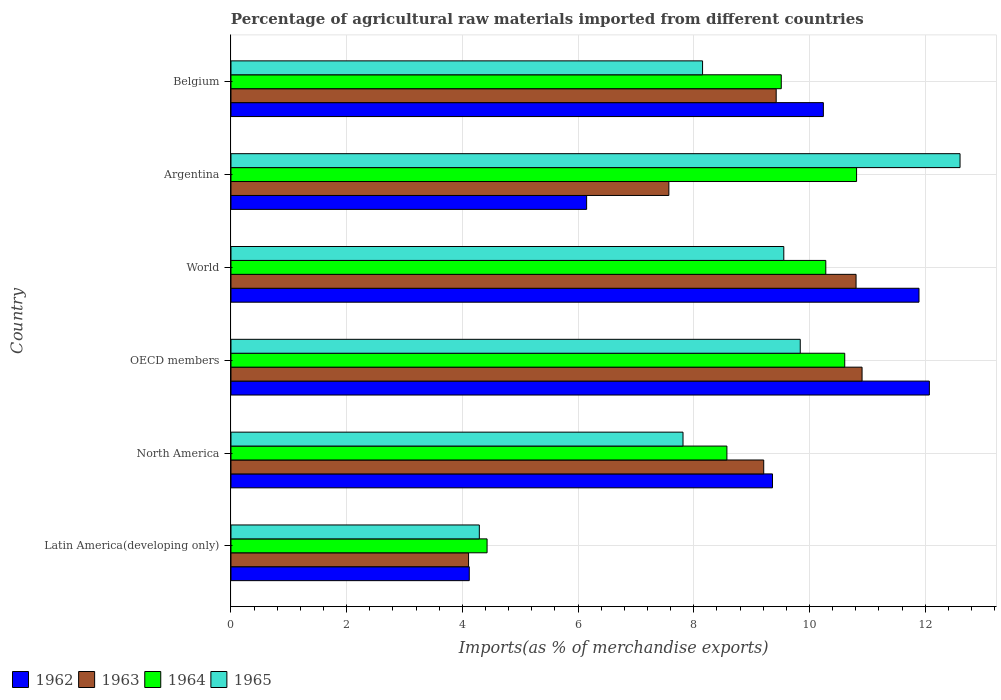How many different coloured bars are there?
Your answer should be very brief. 4. How many groups of bars are there?
Provide a succinct answer. 6. Are the number of bars per tick equal to the number of legend labels?
Offer a very short reply. Yes. Are the number of bars on each tick of the Y-axis equal?
Offer a very short reply. Yes. What is the label of the 2nd group of bars from the top?
Make the answer very short. Argentina. In how many cases, is the number of bars for a given country not equal to the number of legend labels?
Offer a terse response. 0. What is the percentage of imports to different countries in 1962 in Belgium?
Your response must be concise. 10.24. Across all countries, what is the maximum percentage of imports to different countries in 1965?
Ensure brevity in your answer.  12.6. Across all countries, what is the minimum percentage of imports to different countries in 1962?
Give a very brief answer. 4.12. In which country was the percentage of imports to different countries in 1962 minimum?
Offer a very short reply. Latin America(developing only). What is the total percentage of imports to different countries in 1963 in the graph?
Make the answer very short. 52.02. What is the difference between the percentage of imports to different countries in 1965 in Argentina and that in World?
Provide a succinct answer. 3.05. What is the difference between the percentage of imports to different countries in 1962 in OECD members and the percentage of imports to different countries in 1964 in Latin America(developing only)?
Offer a very short reply. 7.64. What is the average percentage of imports to different countries in 1962 per country?
Keep it short and to the point. 8.97. What is the difference between the percentage of imports to different countries in 1962 and percentage of imports to different countries in 1965 in World?
Your answer should be very brief. 2.34. What is the ratio of the percentage of imports to different countries in 1965 in Argentina to that in World?
Offer a terse response. 1.32. Is the difference between the percentage of imports to different countries in 1962 in Argentina and Latin America(developing only) greater than the difference between the percentage of imports to different countries in 1965 in Argentina and Latin America(developing only)?
Provide a succinct answer. No. What is the difference between the highest and the second highest percentage of imports to different countries in 1962?
Give a very brief answer. 0.18. What is the difference between the highest and the lowest percentage of imports to different countries in 1963?
Offer a terse response. 6.8. In how many countries, is the percentage of imports to different countries in 1963 greater than the average percentage of imports to different countries in 1963 taken over all countries?
Your response must be concise. 4. What does the 3rd bar from the bottom in OECD members represents?
Your response must be concise. 1964. Are all the bars in the graph horizontal?
Keep it short and to the point. Yes. How many countries are there in the graph?
Ensure brevity in your answer.  6. What is the difference between two consecutive major ticks on the X-axis?
Provide a succinct answer. 2. Does the graph contain any zero values?
Keep it short and to the point. No. Does the graph contain grids?
Your response must be concise. Yes. Where does the legend appear in the graph?
Ensure brevity in your answer.  Bottom left. How many legend labels are there?
Provide a succinct answer. 4. What is the title of the graph?
Ensure brevity in your answer.  Percentage of agricultural raw materials imported from different countries. What is the label or title of the X-axis?
Keep it short and to the point. Imports(as % of merchandise exports). What is the Imports(as % of merchandise exports) in 1962 in Latin America(developing only)?
Your response must be concise. 4.12. What is the Imports(as % of merchandise exports) of 1963 in Latin America(developing only)?
Your answer should be compact. 4.11. What is the Imports(as % of merchandise exports) in 1964 in Latin America(developing only)?
Make the answer very short. 4.43. What is the Imports(as % of merchandise exports) of 1965 in Latin America(developing only)?
Your answer should be compact. 4.29. What is the Imports(as % of merchandise exports) in 1962 in North America?
Provide a succinct answer. 9.36. What is the Imports(as % of merchandise exports) of 1963 in North America?
Provide a short and direct response. 9.21. What is the Imports(as % of merchandise exports) in 1964 in North America?
Your response must be concise. 8.57. What is the Imports(as % of merchandise exports) in 1965 in North America?
Provide a short and direct response. 7.81. What is the Imports(as % of merchandise exports) in 1962 in OECD members?
Make the answer very short. 12.07. What is the Imports(as % of merchandise exports) of 1963 in OECD members?
Make the answer very short. 10.91. What is the Imports(as % of merchandise exports) in 1964 in OECD members?
Provide a succinct answer. 10.61. What is the Imports(as % of merchandise exports) in 1965 in OECD members?
Your answer should be very brief. 9.84. What is the Imports(as % of merchandise exports) in 1962 in World?
Keep it short and to the point. 11.89. What is the Imports(as % of merchandise exports) in 1963 in World?
Keep it short and to the point. 10.8. What is the Imports(as % of merchandise exports) in 1964 in World?
Your response must be concise. 10.28. What is the Imports(as % of merchandise exports) of 1965 in World?
Make the answer very short. 9.56. What is the Imports(as % of merchandise exports) in 1962 in Argentina?
Your response must be concise. 6.15. What is the Imports(as % of merchandise exports) of 1963 in Argentina?
Ensure brevity in your answer.  7.57. What is the Imports(as % of merchandise exports) of 1964 in Argentina?
Provide a succinct answer. 10.81. What is the Imports(as % of merchandise exports) in 1965 in Argentina?
Provide a short and direct response. 12.6. What is the Imports(as % of merchandise exports) of 1962 in Belgium?
Your answer should be very brief. 10.24. What is the Imports(as % of merchandise exports) of 1963 in Belgium?
Make the answer very short. 9.42. What is the Imports(as % of merchandise exports) of 1964 in Belgium?
Provide a succinct answer. 9.51. What is the Imports(as % of merchandise exports) of 1965 in Belgium?
Your response must be concise. 8.15. Across all countries, what is the maximum Imports(as % of merchandise exports) in 1962?
Provide a succinct answer. 12.07. Across all countries, what is the maximum Imports(as % of merchandise exports) in 1963?
Provide a short and direct response. 10.91. Across all countries, what is the maximum Imports(as % of merchandise exports) of 1964?
Give a very brief answer. 10.81. Across all countries, what is the maximum Imports(as % of merchandise exports) in 1965?
Provide a succinct answer. 12.6. Across all countries, what is the minimum Imports(as % of merchandise exports) of 1962?
Keep it short and to the point. 4.12. Across all countries, what is the minimum Imports(as % of merchandise exports) in 1963?
Your answer should be compact. 4.11. Across all countries, what is the minimum Imports(as % of merchandise exports) in 1964?
Your answer should be compact. 4.43. Across all countries, what is the minimum Imports(as % of merchandise exports) of 1965?
Your answer should be very brief. 4.29. What is the total Imports(as % of merchandise exports) of 1962 in the graph?
Your answer should be compact. 53.83. What is the total Imports(as % of merchandise exports) of 1963 in the graph?
Keep it short and to the point. 52.02. What is the total Imports(as % of merchandise exports) of 1964 in the graph?
Give a very brief answer. 54.21. What is the total Imports(as % of merchandise exports) in 1965 in the graph?
Make the answer very short. 52.25. What is the difference between the Imports(as % of merchandise exports) in 1962 in Latin America(developing only) and that in North America?
Your answer should be compact. -5.24. What is the difference between the Imports(as % of merchandise exports) of 1963 in Latin America(developing only) and that in North America?
Your answer should be very brief. -5.1. What is the difference between the Imports(as % of merchandise exports) in 1964 in Latin America(developing only) and that in North America?
Your answer should be compact. -4.15. What is the difference between the Imports(as % of merchandise exports) of 1965 in Latin America(developing only) and that in North America?
Offer a terse response. -3.52. What is the difference between the Imports(as % of merchandise exports) in 1962 in Latin America(developing only) and that in OECD members?
Make the answer very short. -7.95. What is the difference between the Imports(as % of merchandise exports) of 1963 in Latin America(developing only) and that in OECD members?
Your answer should be compact. -6.8. What is the difference between the Imports(as % of merchandise exports) of 1964 in Latin America(developing only) and that in OECD members?
Give a very brief answer. -6.18. What is the difference between the Imports(as % of merchandise exports) of 1965 in Latin America(developing only) and that in OECD members?
Make the answer very short. -5.55. What is the difference between the Imports(as % of merchandise exports) of 1962 in Latin America(developing only) and that in World?
Make the answer very short. -7.77. What is the difference between the Imports(as % of merchandise exports) in 1963 in Latin America(developing only) and that in World?
Your answer should be compact. -6.7. What is the difference between the Imports(as % of merchandise exports) of 1964 in Latin America(developing only) and that in World?
Keep it short and to the point. -5.85. What is the difference between the Imports(as % of merchandise exports) of 1965 in Latin America(developing only) and that in World?
Ensure brevity in your answer.  -5.26. What is the difference between the Imports(as % of merchandise exports) of 1962 in Latin America(developing only) and that in Argentina?
Provide a succinct answer. -2.03. What is the difference between the Imports(as % of merchandise exports) in 1963 in Latin America(developing only) and that in Argentina?
Your answer should be very brief. -3.46. What is the difference between the Imports(as % of merchandise exports) of 1964 in Latin America(developing only) and that in Argentina?
Your answer should be very brief. -6.39. What is the difference between the Imports(as % of merchandise exports) in 1965 in Latin America(developing only) and that in Argentina?
Keep it short and to the point. -8.31. What is the difference between the Imports(as % of merchandise exports) in 1962 in Latin America(developing only) and that in Belgium?
Ensure brevity in your answer.  -6.12. What is the difference between the Imports(as % of merchandise exports) of 1963 in Latin America(developing only) and that in Belgium?
Provide a short and direct response. -5.32. What is the difference between the Imports(as % of merchandise exports) of 1964 in Latin America(developing only) and that in Belgium?
Ensure brevity in your answer.  -5.08. What is the difference between the Imports(as % of merchandise exports) of 1965 in Latin America(developing only) and that in Belgium?
Keep it short and to the point. -3.86. What is the difference between the Imports(as % of merchandise exports) in 1962 in North America and that in OECD members?
Give a very brief answer. -2.71. What is the difference between the Imports(as % of merchandise exports) in 1963 in North America and that in OECD members?
Your response must be concise. -1.7. What is the difference between the Imports(as % of merchandise exports) in 1964 in North America and that in OECD members?
Offer a very short reply. -2.04. What is the difference between the Imports(as % of merchandise exports) in 1965 in North America and that in OECD members?
Your answer should be compact. -2.03. What is the difference between the Imports(as % of merchandise exports) of 1962 in North America and that in World?
Offer a terse response. -2.53. What is the difference between the Imports(as % of merchandise exports) of 1963 in North America and that in World?
Your response must be concise. -1.6. What is the difference between the Imports(as % of merchandise exports) of 1964 in North America and that in World?
Offer a very short reply. -1.71. What is the difference between the Imports(as % of merchandise exports) in 1965 in North America and that in World?
Offer a terse response. -1.74. What is the difference between the Imports(as % of merchandise exports) in 1962 in North America and that in Argentina?
Make the answer very short. 3.21. What is the difference between the Imports(as % of merchandise exports) in 1963 in North America and that in Argentina?
Keep it short and to the point. 1.64. What is the difference between the Imports(as % of merchandise exports) in 1964 in North America and that in Argentina?
Your answer should be very brief. -2.24. What is the difference between the Imports(as % of merchandise exports) in 1965 in North America and that in Argentina?
Offer a terse response. -4.79. What is the difference between the Imports(as % of merchandise exports) of 1962 in North America and that in Belgium?
Offer a terse response. -0.88. What is the difference between the Imports(as % of merchandise exports) in 1963 in North America and that in Belgium?
Keep it short and to the point. -0.22. What is the difference between the Imports(as % of merchandise exports) of 1964 in North America and that in Belgium?
Offer a terse response. -0.94. What is the difference between the Imports(as % of merchandise exports) of 1965 in North America and that in Belgium?
Your answer should be compact. -0.34. What is the difference between the Imports(as % of merchandise exports) in 1962 in OECD members and that in World?
Your answer should be very brief. 0.18. What is the difference between the Imports(as % of merchandise exports) of 1963 in OECD members and that in World?
Make the answer very short. 0.1. What is the difference between the Imports(as % of merchandise exports) in 1964 in OECD members and that in World?
Your answer should be very brief. 0.33. What is the difference between the Imports(as % of merchandise exports) in 1965 in OECD members and that in World?
Your response must be concise. 0.28. What is the difference between the Imports(as % of merchandise exports) in 1962 in OECD members and that in Argentina?
Your answer should be compact. 5.92. What is the difference between the Imports(as % of merchandise exports) in 1963 in OECD members and that in Argentina?
Give a very brief answer. 3.34. What is the difference between the Imports(as % of merchandise exports) of 1964 in OECD members and that in Argentina?
Keep it short and to the point. -0.2. What is the difference between the Imports(as % of merchandise exports) of 1965 in OECD members and that in Argentina?
Your response must be concise. -2.76. What is the difference between the Imports(as % of merchandise exports) of 1962 in OECD members and that in Belgium?
Ensure brevity in your answer.  1.83. What is the difference between the Imports(as % of merchandise exports) in 1963 in OECD members and that in Belgium?
Give a very brief answer. 1.48. What is the difference between the Imports(as % of merchandise exports) of 1964 in OECD members and that in Belgium?
Offer a terse response. 1.1. What is the difference between the Imports(as % of merchandise exports) in 1965 in OECD members and that in Belgium?
Keep it short and to the point. 1.69. What is the difference between the Imports(as % of merchandise exports) of 1962 in World and that in Argentina?
Ensure brevity in your answer.  5.74. What is the difference between the Imports(as % of merchandise exports) of 1963 in World and that in Argentina?
Offer a very short reply. 3.24. What is the difference between the Imports(as % of merchandise exports) in 1964 in World and that in Argentina?
Your response must be concise. -0.53. What is the difference between the Imports(as % of merchandise exports) of 1965 in World and that in Argentina?
Keep it short and to the point. -3.05. What is the difference between the Imports(as % of merchandise exports) in 1962 in World and that in Belgium?
Your response must be concise. 1.65. What is the difference between the Imports(as % of merchandise exports) of 1963 in World and that in Belgium?
Offer a terse response. 1.38. What is the difference between the Imports(as % of merchandise exports) in 1964 in World and that in Belgium?
Make the answer very short. 0.77. What is the difference between the Imports(as % of merchandise exports) in 1965 in World and that in Belgium?
Give a very brief answer. 1.4. What is the difference between the Imports(as % of merchandise exports) in 1962 in Argentina and that in Belgium?
Offer a terse response. -4.09. What is the difference between the Imports(as % of merchandise exports) of 1963 in Argentina and that in Belgium?
Offer a very short reply. -1.86. What is the difference between the Imports(as % of merchandise exports) of 1964 in Argentina and that in Belgium?
Provide a succinct answer. 1.3. What is the difference between the Imports(as % of merchandise exports) of 1965 in Argentina and that in Belgium?
Provide a succinct answer. 4.45. What is the difference between the Imports(as % of merchandise exports) in 1962 in Latin America(developing only) and the Imports(as % of merchandise exports) in 1963 in North America?
Keep it short and to the point. -5.09. What is the difference between the Imports(as % of merchandise exports) in 1962 in Latin America(developing only) and the Imports(as % of merchandise exports) in 1964 in North America?
Provide a short and direct response. -4.45. What is the difference between the Imports(as % of merchandise exports) of 1962 in Latin America(developing only) and the Imports(as % of merchandise exports) of 1965 in North America?
Give a very brief answer. -3.69. What is the difference between the Imports(as % of merchandise exports) of 1963 in Latin America(developing only) and the Imports(as % of merchandise exports) of 1964 in North America?
Make the answer very short. -4.47. What is the difference between the Imports(as % of merchandise exports) of 1963 in Latin America(developing only) and the Imports(as % of merchandise exports) of 1965 in North America?
Provide a short and direct response. -3.71. What is the difference between the Imports(as % of merchandise exports) of 1964 in Latin America(developing only) and the Imports(as % of merchandise exports) of 1965 in North America?
Your answer should be very brief. -3.39. What is the difference between the Imports(as % of merchandise exports) in 1962 in Latin America(developing only) and the Imports(as % of merchandise exports) in 1963 in OECD members?
Offer a very short reply. -6.79. What is the difference between the Imports(as % of merchandise exports) in 1962 in Latin America(developing only) and the Imports(as % of merchandise exports) in 1964 in OECD members?
Give a very brief answer. -6.49. What is the difference between the Imports(as % of merchandise exports) of 1962 in Latin America(developing only) and the Imports(as % of merchandise exports) of 1965 in OECD members?
Keep it short and to the point. -5.72. What is the difference between the Imports(as % of merchandise exports) in 1963 in Latin America(developing only) and the Imports(as % of merchandise exports) in 1964 in OECD members?
Offer a terse response. -6.5. What is the difference between the Imports(as % of merchandise exports) of 1963 in Latin America(developing only) and the Imports(as % of merchandise exports) of 1965 in OECD members?
Your answer should be compact. -5.73. What is the difference between the Imports(as % of merchandise exports) in 1964 in Latin America(developing only) and the Imports(as % of merchandise exports) in 1965 in OECD members?
Ensure brevity in your answer.  -5.41. What is the difference between the Imports(as % of merchandise exports) of 1962 in Latin America(developing only) and the Imports(as % of merchandise exports) of 1963 in World?
Make the answer very short. -6.69. What is the difference between the Imports(as % of merchandise exports) in 1962 in Latin America(developing only) and the Imports(as % of merchandise exports) in 1964 in World?
Offer a terse response. -6.16. What is the difference between the Imports(as % of merchandise exports) of 1962 in Latin America(developing only) and the Imports(as % of merchandise exports) of 1965 in World?
Your answer should be compact. -5.44. What is the difference between the Imports(as % of merchandise exports) in 1963 in Latin America(developing only) and the Imports(as % of merchandise exports) in 1964 in World?
Provide a succinct answer. -6.17. What is the difference between the Imports(as % of merchandise exports) in 1963 in Latin America(developing only) and the Imports(as % of merchandise exports) in 1965 in World?
Offer a terse response. -5.45. What is the difference between the Imports(as % of merchandise exports) of 1964 in Latin America(developing only) and the Imports(as % of merchandise exports) of 1965 in World?
Your answer should be very brief. -5.13. What is the difference between the Imports(as % of merchandise exports) of 1962 in Latin America(developing only) and the Imports(as % of merchandise exports) of 1963 in Argentina?
Your response must be concise. -3.45. What is the difference between the Imports(as % of merchandise exports) of 1962 in Latin America(developing only) and the Imports(as % of merchandise exports) of 1964 in Argentina?
Offer a terse response. -6.69. What is the difference between the Imports(as % of merchandise exports) of 1962 in Latin America(developing only) and the Imports(as % of merchandise exports) of 1965 in Argentina?
Provide a succinct answer. -8.48. What is the difference between the Imports(as % of merchandise exports) of 1963 in Latin America(developing only) and the Imports(as % of merchandise exports) of 1964 in Argentina?
Your response must be concise. -6.71. What is the difference between the Imports(as % of merchandise exports) of 1963 in Latin America(developing only) and the Imports(as % of merchandise exports) of 1965 in Argentina?
Ensure brevity in your answer.  -8.49. What is the difference between the Imports(as % of merchandise exports) of 1964 in Latin America(developing only) and the Imports(as % of merchandise exports) of 1965 in Argentina?
Ensure brevity in your answer.  -8.17. What is the difference between the Imports(as % of merchandise exports) of 1962 in Latin America(developing only) and the Imports(as % of merchandise exports) of 1963 in Belgium?
Keep it short and to the point. -5.3. What is the difference between the Imports(as % of merchandise exports) of 1962 in Latin America(developing only) and the Imports(as % of merchandise exports) of 1964 in Belgium?
Provide a short and direct response. -5.39. What is the difference between the Imports(as % of merchandise exports) in 1962 in Latin America(developing only) and the Imports(as % of merchandise exports) in 1965 in Belgium?
Offer a very short reply. -4.03. What is the difference between the Imports(as % of merchandise exports) of 1963 in Latin America(developing only) and the Imports(as % of merchandise exports) of 1964 in Belgium?
Give a very brief answer. -5.4. What is the difference between the Imports(as % of merchandise exports) of 1963 in Latin America(developing only) and the Imports(as % of merchandise exports) of 1965 in Belgium?
Your answer should be compact. -4.04. What is the difference between the Imports(as % of merchandise exports) in 1964 in Latin America(developing only) and the Imports(as % of merchandise exports) in 1965 in Belgium?
Offer a very short reply. -3.72. What is the difference between the Imports(as % of merchandise exports) of 1962 in North America and the Imports(as % of merchandise exports) of 1963 in OECD members?
Make the answer very short. -1.55. What is the difference between the Imports(as % of merchandise exports) in 1962 in North America and the Imports(as % of merchandise exports) in 1964 in OECD members?
Make the answer very short. -1.25. What is the difference between the Imports(as % of merchandise exports) in 1962 in North America and the Imports(as % of merchandise exports) in 1965 in OECD members?
Provide a short and direct response. -0.48. What is the difference between the Imports(as % of merchandise exports) of 1963 in North America and the Imports(as % of merchandise exports) of 1964 in OECD members?
Your answer should be very brief. -1.4. What is the difference between the Imports(as % of merchandise exports) in 1963 in North America and the Imports(as % of merchandise exports) in 1965 in OECD members?
Your answer should be very brief. -0.63. What is the difference between the Imports(as % of merchandise exports) of 1964 in North America and the Imports(as % of merchandise exports) of 1965 in OECD members?
Ensure brevity in your answer.  -1.27. What is the difference between the Imports(as % of merchandise exports) in 1962 in North America and the Imports(as % of merchandise exports) in 1963 in World?
Your answer should be very brief. -1.44. What is the difference between the Imports(as % of merchandise exports) of 1962 in North America and the Imports(as % of merchandise exports) of 1964 in World?
Offer a very short reply. -0.92. What is the difference between the Imports(as % of merchandise exports) of 1962 in North America and the Imports(as % of merchandise exports) of 1965 in World?
Offer a very short reply. -0.2. What is the difference between the Imports(as % of merchandise exports) of 1963 in North America and the Imports(as % of merchandise exports) of 1964 in World?
Give a very brief answer. -1.07. What is the difference between the Imports(as % of merchandise exports) in 1963 in North America and the Imports(as % of merchandise exports) in 1965 in World?
Provide a succinct answer. -0.35. What is the difference between the Imports(as % of merchandise exports) of 1964 in North America and the Imports(as % of merchandise exports) of 1965 in World?
Your answer should be compact. -0.98. What is the difference between the Imports(as % of merchandise exports) of 1962 in North America and the Imports(as % of merchandise exports) of 1963 in Argentina?
Your answer should be very brief. 1.79. What is the difference between the Imports(as % of merchandise exports) of 1962 in North America and the Imports(as % of merchandise exports) of 1964 in Argentina?
Give a very brief answer. -1.45. What is the difference between the Imports(as % of merchandise exports) of 1962 in North America and the Imports(as % of merchandise exports) of 1965 in Argentina?
Your answer should be compact. -3.24. What is the difference between the Imports(as % of merchandise exports) in 1963 in North America and the Imports(as % of merchandise exports) in 1964 in Argentina?
Offer a terse response. -1.61. What is the difference between the Imports(as % of merchandise exports) in 1963 in North America and the Imports(as % of merchandise exports) in 1965 in Argentina?
Provide a short and direct response. -3.39. What is the difference between the Imports(as % of merchandise exports) of 1964 in North America and the Imports(as % of merchandise exports) of 1965 in Argentina?
Offer a very short reply. -4.03. What is the difference between the Imports(as % of merchandise exports) in 1962 in North America and the Imports(as % of merchandise exports) in 1963 in Belgium?
Your response must be concise. -0.06. What is the difference between the Imports(as % of merchandise exports) in 1962 in North America and the Imports(as % of merchandise exports) in 1964 in Belgium?
Offer a very short reply. -0.15. What is the difference between the Imports(as % of merchandise exports) in 1962 in North America and the Imports(as % of merchandise exports) in 1965 in Belgium?
Offer a very short reply. 1.21. What is the difference between the Imports(as % of merchandise exports) of 1963 in North America and the Imports(as % of merchandise exports) of 1964 in Belgium?
Keep it short and to the point. -0.3. What is the difference between the Imports(as % of merchandise exports) in 1963 in North America and the Imports(as % of merchandise exports) in 1965 in Belgium?
Your answer should be compact. 1.06. What is the difference between the Imports(as % of merchandise exports) of 1964 in North America and the Imports(as % of merchandise exports) of 1965 in Belgium?
Ensure brevity in your answer.  0.42. What is the difference between the Imports(as % of merchandise exports) in 1962 in OECD members and the Imports(as % of merchandise exports) in 1963 in World?
Make the answer very short. 1.27. What is the difference between the Imports(as % of merchandise exports) of 1962 in OECD members and the Imports(as % of merchandise exports) of 1964 in World?
Your answer should be very brief. 1.79. What is the difference between the Imports(as % of merchandise exports) of 1962 in OECD members and the Imports(as % of merchandise exports) of 1965 in World?
Your response must be concise. 2.52. What is the difference between the Imports(as % of merchandise exports) in 1963 in OECD members and the Imports(as % of merchandise exports) in 1964 in World?
Provide a succinct answer. 0.63. What is the difference between the Imports(as % of merchandise exports) in 1963 in OECD members and the Imports(as % of merchandise exports) in 1965 in World?
Provide a succinct answer. 1.35. What is the difference between the Imports(as % of merchandise exports) of 1964 in OECD members and the Imports(as % of merchandise exports) of 1965 in World?
Your answer should be very brief. 1.05. What is the difference between the Imports(as % of merchandise exports) of 1962 in OECD members and the Imports(as % of merchandise exports) of 1963 in Argentina?
Your answer should be very brief. 4.5. What is the difference between the Imports(as % of merchandise exports) of 1962 in OECD members and the Imports(as % of merchandise exports) of 1964 in Argentina?
Provide a short and direct response. 1.26. What is the difference between the Imports(as % of merchandise exports) in 1962 in OECD members and the Imports(as % of merchandise exports) in 1965 in Argentina?
Your answer should be compact. -0.53. What is the difference between the Imports(as % of merchandise exports) of 1963 in OECD members and the Imports(as % of merchandise exports) of 1964 in Argentina?
Your response must be concise. 0.09. What is the difference between the Imports(as % of merchandise exports) in 1963 in OECD members and the Imports(as % of merchandise exports) in 1965 in Argentina?
Your response must be concise. -1.69. What is the difference between the Imports(as % of merchandise exports) in 1964 in OECD members and the Imports(as % of merchandise exports) in 1965 in Argentina?
Your answer should be compact. -1.99. What is the difference between the Imports(as % of merchandise exports) of 1962 in OECD members and the Imports(as % of merchandise exports) of 1963 in Belgium?
Offer a very short reply. 2.65. What is the difference between the Imports(as % of merchandise exports) of 1962 in OECD members and the Imports(as % of merchandise exports) of 1964 in Belgium?
Your answer should be compact. 2.56. What is the difference between the Imports(as % of merchandise exports) of 1962 in OECD members and the Imports(as % of merchandise exports) of 1965 in Belgium?
Keep it short and to the point. 3.92. What is the difference between the Imports(as % of merchandise exports) of 1963 in OECD members and the Imports(as % of merchandise exports) of 1964 in Belgium?
Offer a terse response. 1.4. What is the difference between the Imports(as % of merchandise exports) of 1963 in OECD members and the Imports(as % of merchandise exports) of 1965 in Belgium?
Provide a short and direct response. 2.76. What is the difference between the Imports(as % of merchandise exports) in 1964 in OECD members and the Imports(as % of merchandise exports) in 1965 in Belgium?
Your answer should be compact. 2.46. What is the difference between the Imports(as % of merchandise exports) of 1962 in World and the Imports(as % of merchandise exports) of 1963 in Argentina?
Keep it short and to the point. 4.32. What is the difference between the Imports(as % of merchandise exports) of 1962 in World and the Imports(as % of merchandise exports) of 1964 in Argentina?
Give a very brief answer. 1.08. What is the difference between the Imports(as % of merchandise exports) of 1962 in World and the Imports(as % of merchandise exports) of 1965 in Argentina?
Your response must be concise. -0.71. What is the difference between the Imports(as % of merchandise exports) of 1963 in World and the Imports(as % of merchandise exports) of 1964 in Argentina?
Your response must be concise. -0.01. What is the difference between the Imports(as % of merchandise exports) of 1963 in World and the Imports(as % of merchandise exports) of 1965 in Argentina?
Your answer should be compact. -1.8. What is the difference between the Imports(as % of merchandise exports) of 1964 in World and the Imports(as % of merchandise exports) of 1965 in Argentina?
Your answer should be very brief. -2.32. What is the difference between the Imports(as % of merchandise exports) in 1962 in World and the Imports(as % of merchandise exports) in 1963 in Belgium?
Provide a short and direct response. 2.47. What is the difference between the Imports(as % of merchandise exports) in 1962 in World and the Imports(as % of merchandise exports) in 1964 in Belgium?
Ensure brevity in your answer.  2.38. What is the difference between the Imports(as % of merchandise exports) of 1962 in World and the Imports(as % of merchandise exports) of 1965 in Belgium?
Ensure brevity in your answer.  3.74. What is the difference between the Imports(as % of merchandise exports) of 1963 in World and the Imports(as % of merchandise exports) of 1964 in Belgium?
Give a very brief answer. 1.29. What is the difference between the Imports(as % of merchandise exports) of 1963 in World and the Imports(as % of merchandise exports) of 1965 in Belgium?
Make the answer very short. 2.65. What is the difference between the Imports(as % of merchandise exports) in 1964 in World and the Imports(as % of merchandise exports) in 1965 in Belgium?
Offer a terse response. 2.13. What is the difference between the Imports(as % of merchandise exports) of 1962 in Argentina and the Imports(as % of merchandise exports) of 1963 in Belgium?
Your answer should be very brief. -3.28. What is the difference between the Imports(as % of merchandise exports) of 1962 in Argentina and the Imports(as % of merchandise exports) of 1964 in Belgium?
Your answer should be very brief. -3.36. What is the difference between the Imports(as % of merchandise exports) of 1962 in Argentina and the Imports(as % of merchandise exports) of 1965 in Belgium?
Provide a succinct answer. -2. What is the difference between the Imports(as % of merchandise exports) of 1963 in Argentina and the Imports(as % of merchandise exports) of 1964 in Belgium?
Keep it short and to the point. -1.94. What is the difference between the Imports(as % of merchandise exports) of 1963 in Argentina and the Imports(as % of merchandise exports) of 1965 in Belgium?
Make the answer very short. -0.58. What is the difference between the Imports(as % of merchandise exports) in 1964 in Argentina and the Imports(as % of merchandise exports) in 1965 in Belgium?
Give a very brief answer. 2.66. What is the average Imports(as % of merchandise exports) in 1962 per country?
Keep it short and to the point. 8.97. What is the average Imports(as % of merchandise exports) of 1963 per country?
Your response must be concise. 8.67. What is the average Imports(as % of merchandise exports) of 1964 per country?
Your answer should be compact. 9.04. What is the average Imports(as % of merchandise exports) in 1965 per country?
Provide a succinct answer. 8.71. What is the difference between the Imports(as % of merchandise exports) in 1962 and Imports(as % of merchandise exports) in 1963 in Latin America(developing only)?
Provide a succinct answer. 0.01. What is the difference between the Imports(as % of merchandise exports) in 1962 and Imports(as % of merchandise exports) in 1964 in Latin America(developing only)?
Your answer should be very brief. -0.31. What is the difference between the Imports(as % of merchandise exports) of 1962 and Imports(as % of merchandise exports) of 1965 in Latin America(developing only)?
Ensure brevity in your answer.  -0.17. What is the difference between the Imports(as % of merchandise exports) in 1963 and Imports(as % of merchandise exports) in 1964 in Latin America(developing only)?
Ensure brevity in your answer.  -0.32. What is the difference between the Imports(as % of merchandise exports) in 1963 and Imports(as % of merchandise exports) in 1965 in Latin America(developing only)?
Your answer should be compact. -0.19. What is the difference between the Imports(as % of merchandise exports) of 1964 and Imports(as % of merchandise exports) of 1965 in Latin America(developing only)?
Provide a short and direct response. 0.13. What is the difference between the Imports(as % of merchandise exports) of 1962 and Imports(as % of merchandise exports) of 1963 in North America?
Provide a short and direct response. 0.15. What is the difference between the Imports(as % of merchandise exports) in 1962 and Imports(as % of merchandise exports) in 1964 in North America?
Make the answer very short. 0.79. What is the difference between the Imports(as % of merchandise exports) in 1962 and Imports(as % of merchandise exports) in 1965 in North America?
Provide a short and direct response. 1.55. What is the difference between the Imports(as % of merchandise exports) in 1963 and Imports(as % of merchandise exports) in 1964 in North America?
Your answer should be very brief. 0.64. What is the difference between the Imports(as % of merchandise exports) of 1963 and Imports(as % of merchandise exports) of 1965 in North America?
Offer a very short reply. 1.39. What is the difference between the Imports(as % of merchandise exports) of 1964 and Imports(as % of merchandise exports) of 1965 in North America?
Your answer should be compact. 0.76. What is the difference between the Imports(as % of merchandise exports) in 1962 and Imports(as % of merchandise exports) in 1963 in OECD members?
Provide a short and direct response. 1.16. What is the difference between the Imports(as % of merchandise exports) in 1962 and Imports(as % of merchandise exports) in 1964 in OECD members?
Your answer should be compact. 1.46. What is the difference between the Imports(as % of merchandise exports) of 1962 and Imports(as % of merchandise exports) of 1965 in OECD members?
Offer a terse response. 2.23. What is the difference between the Imports(as % of merchandise exports) in 1963 and Imports(as % of merchandise exports) in 1964 in OECD members?
Provide a succinct answer. 0.3. What is the difference between the Imports(as % of merchandise exports) of 1963 and Imports(as % of merchandise exports) of 1965 in OECD members?
Offer a very short reply. 1.07. What is the difference between the Imports(as % of merchandise exports) of 1964 and Imports(as % of merchandise exports) of 1965 in OECD members?
Your response must be concise. 0.77. What is the difference between the Imports(as % of merchandise exports) in 1962 and Imports(as % of merchandise exports) in 1963 in World?
Offer a terse response. 1.09. What is the difference between the Imports(as % of merchandise exports) of 1962 and Imports(as % of merchandise exports) of 1964 in World?
Make the answer very short. 1.61. What is the difference between the Imports(as % of merchandise exports) of 1962 and Imports(as % of merchandise exports) of 1965 in World?
Your answer should be very brief. 2.34. What is the difference between the Imports(as % of merchandise exports) of 1963 and Imports(as % of merchandise exports) of 1964 in World?
Provide a succinct answer. 0.52. What is the difference between the Imports(as % of merchandise exports) in 1963 and Imports(as % of merchandise exports) in 1965 in World?
Give a very brief answer. 1.25. What is the difference between the Imports(as % of merchandise exports) of 1964 and Imports(as % of merchandise exports) of 1965 in World?
Offer a very short reply. 0.73. What is the difference between the Imports(as % of merchandise exports) in 1962 and Imports(as % of merchandise exports) in 1963 in Argentina?
Give a very brief answer. -1.42. What is the difference between the Imports(as % of merchandise exports) of 1962 and Imports(as % of merchandise exports) of 1964 in Argentina?
Keep it short and to the point. -4.67. What is the difference between the Imports(as % of merchandise exports) in 1962 and Imports(as % of merchandise exports) in 1965 in Argentina?
Offer a terse response. -6.45. What is the difference between the Imports(as % of merchandise exports) of 1963 and Imports(as % of merchandise exports) of 1964 in Argentina?
Ensure brevity in your answer.  -3.24. What is the difference between the Imports(as % of merchandise exports) of 1963 and Imports(as % of merchandise exports) of 1965 in Argentina?
Offer a very short reply. -5.03. What is the difference between the Imports(as % of merchandise exports) of 1964 and Imports(as % of merchandise exports) of 1965 in Argentina?
Your response must be concise. -1.79. What is the difference between the Imports(as % of merchandise exports) in 1962 and Imports(as % of merchandise exports) in 1963 in Belgium?
Your answer should be compact. 0.82. What is the difference between the Imports(as % of merchandise exports) in 1962 and Imports(as % of merchandise exports) in 1964 in Belgium?
Keep it short and to the point. 0.73. What is the difference between the Imports(as % of merchandise exports) in 1962 and Imports(as % of merchandise exports) in 1965 in Belgium?
Give a very brief answer. 2.09. What is the difference between the Imports(as % of merchandise exports) in 1963 and Imports(as % of merchandise exports) in 1964 in Belgium?
Your answer should be compact. -0.09. What is the difference between the Imports(as % of merchandise exports) of 1963 and Imports(as % of merchandise exports) of 1965 in Belgium?
Your answer should be compact. 1.27. What is the difference between the Imports(as % of merchandise exports) of 1964 and Imports(as % of merchandise exports) of 1965 in Belgium?
Offer a very short reply. 1.36. What is the ratio of the Imports(as % of merchandise exports) in 1962 in Latin America(developing only) to that in North America?
Offer a terse response. 0.44. What is the ratio of the Imports(as % of merchandise exports) in 1963 in Latin America(developing only) to that in North America?
Offer a terse response. 0.45. What is the ratio of the Imports(as % of merchandise exports) in 1964 in Latin America(developing only) to that in North America?
Give a very brief answer. 0.52. What is the ratio of the Imports(as % of merchandise exports) of 1965 in Latin America(developing only) to that in North America?
Offer a terse response. 0.55. What is the ratio of the Imports(as % of merchandise exports) of 1962 in Latin America(developing only) to that in OECD members?
Provide a succinct answer. 0.34. What is the ratio of the Imports(as % of merchandise exports) of 1963 in Latin America(developing only) to that in OECD members?
Provide a succinct answer. 0.38. What is the ratio of the Imports(as % of merchandise exports) in 1964 in Latin America(developing only) to that in OECD members?
Your answer should be compact. 0.42. What is the ratio of the Imports(as % of merchandise exports) of 1965 in Latin America(developing only) to that in OECD members?
Your answer should be very brief. 0.44. What is the ratio of the Imports(as % of merchandise exports) in 1962 in Latin America(developing only) to that in World?
Make the answer very short. 0.35. What is the ratio of the Imports(as % of merchandise exports) of 1963 in Latin America(developing only) to that in World?
Your response must be concise. 0.38. What is the ratio of the Imports(as % of merchandise exports) in 1964 in Latin America(developing only) to that in World?
Ensure brevity in your answer.  0.43. What is the ratio of the Imports(as % of merchandise exports) of 1965 in Latin America(developing only) to that in World?
Provide a succinct answer. 0.45. What is the ratio of the Imports(as % of merchandise exports) in 1962 in Latin America(developing only) to that in Argentina?
Your answer should be compact. 0.67. What is the ratio of the Imports(as % of merchandise exports) in 1963 in Latin America(developing only) to that in Argentina?
Provide a succinct answer. 0.54. What is the ratio of the Imports(as % of merchandise exports) in 1964 in Latin America(developing only) to that in Argentina?
Offer a very short reply. 0.41. What is the ratio of the Imports(as % of merchandise exports) in 1965 in Latin America(developing only) to that in Argentina?
Make the answer very short. 0.34. What is the ratio of the Imports(as % of merchandise exports) of 1962 in Latin America(developing only) to that in Belgium?
Offer a terse response. 0.4. What is the ratio of the Imports(as % of merchandise exports) of 1963 in Latin America(developing only) to that in Belgium?
Offer a terse response. 0.44. What is the ratio of the Imports(as % of merchandise exports) in 1964 in Latin America(developing only) to that in Belgium?
Your answer should be compact. 0.47. What is the ratio of the Imports(as % of merchandise exports) in 1965 in Latin America(developing only) to that in Belgium?
Provide a succinct answer. 0.53. What is the ratio of the Imports(as % of merchandise exports) in 1962 in North America to that in OECD members?
Ensure brevity in your answer.  0.78. What is the ratio of the Imports(as % of merchandise exports) of 1963 in North America to that in OECD members?
Offer a terse response. 0.84. What is the ratio of the Imports(as % of merchandise exports) of 1964 in North America to that in OECD members?
Provide a short and direct response. 0.81. What is the ratio of the Imports(as % of merchandise exports) in 1965 in North America to that in OECD members?
Offer a very short reply. 0.79. What is the ratio of the Imports(as % of merchandise exports) of 1962 in North America to that in World?
Ensure brevity in your answer.  0.79. What is the ratio of the Imports(as % of merchandise exports) in 1963 in North America to that in World?
Ensure brevity in your answer.  0.85. What is the ratio of the Imports(as % of merchandise exports) in 1964 in North America to that in World?
Offer a very short reply. 0.83. What is the ratio of the Imports(as % of merchandise exports) of 1965 in North America to that in World?
Offer a very short reply. 0.82. What is the ratio of the Imports(as % of merchandise exports) in 1962 in North America to that in Argentina?
Your response must be concise. 1.52. What is the ratio of the Imports(as % of merchandise exports) in 1963 in North America to that in Argentina?
Offer a terse response. 1.22. What is the ratio of the Imports(as % of merchandise exports) of 1964 in North America to that in Argentina?
Ensure brevity in your answer.  0.79. What is the ratio of the Imports(as % of merchandise exports) of 1965 in North America to that in Argentina?
Keep it short and to the point. 0.62. What is the ratio of the Imports(as % of merchandise exports) of 1962 in North America to that in Belgium?
Keep it short and to the point. 0.91. What is the ratio of the Imports(as % of merchandise exports) of 1963 in North America to that in Belgium?
Make the answer very short. 0.98. What is the ratio of the Imports(as % of merchandise exports) in 1964 in North America to that in Belgium?
Give a very brief answer. 0.9. What is the ratio of the Imports(as % of merchandise exports) of 1965 in North America to that in Belgium?
Ensure brevity in your answer.  0.96. What is the ratio of the Imports(as % of merchandise exports) in 1962 in OECD members to that in World?
Give a very brief answer. 1.02. What is the ratio of the Imports(as % of merchandise exports) in 1963 in OECD members to that in World?
Ensure brevity in your answer.  1.01. What is the ratio of the Imports(as % of merchandise exports) in 1964 in OECD members to that in World?
Your answer should be compact. 1.03. What is the ratio of the Imports(as % of merchandise exports) in 1965 in OECD members to that in World?
Your answer should be compact. 1.03. What is the ratio of the Imports(as % of merchandise exports) of 1962 in OECD members to that in Argentina?
Provide a short and direct response. 1.96. What is the ratio of the Imports(as % of merchandise exports) in 1963 in OECD members to that in Argentina?
Make the answer very short. 1.44. What is the ratio of the Imports(as % of merchandise exports) in 1964 in OECD members to that in Argentina?
Your answer should be very brief. 0.98. What is the ratio of the Imports(as % of merchandise exports) in 1965 in OECD members to that in Argentina?
Your response must be concise. 0.78. What is the ratio of the Imports(as % of merchandise exports) in 1962 in OECD members to that in Belgium?
Offer a terse response. 1.18. What is the ratio of the Imports(as % of merchandise exports) of 1963 in OECD members to that in Belgium?
Offer a terse response. 1.16. What is the ratio of the Imports(as % of merchandise exports) of 1964 in OECD members to that in Belgium?
Provide a succinct answer. 1.12. What is the ratio of the Imports(as % of merchandise exports) in 1965 in OECD members to that in Belgium?
Offer a very short reply. 1.21. What is the ratio of the Imports(as % of merchandise exports) of 1962 in World to that in Argentina?
Keep it short and to the point. 1.93. What is the ratio of the Imports(as % of merchandise exports) in 1963 in World to that in Argentina?
Ensure brevity in your answer.  1.43. What is the ratio of the Imports(as % of merchandise exports) in 1964 in World to that in Argentina?
Make the answer very short. 0.95. What is the ratio of the Imports(as % of merchandise exports) of 1965 in World to that in Argentina?
Your answer should be very brief. 0.76. What is the ratio of the Imports(as % of merchandise exports) of 1962 in World to that in Belgium?
Your response must be concise. 1.16. What is the ratio of the Imports(as % of merchandise exports) in 1963 in World to that in Belgium?
Make the answer very short. 1.15. What is the ratio of the Imports(as % of merchandise exports) in 1964 in World to that in Belgium?
Keep it short and to the point. 1.08. What is the ratio of the Imports(as % of merchandise exports) in 1965 in World to that in Belgium?
Offer a terse response. 1.17. What is the ratio of the Imports(as % of merchandise exports) in 1962 in Argentina to that in Belgium?
Your answer should be compact. 0.6. What is the ratio of the Imports(as % of merchandise exports) in 1963 in Argentina to that in Belgium?
Ensure brevity in your answer.  0.8. What is the ratio of the Imports(as % of merchandise exports) of 1964 in Argentina to that in Belgium?
Give a very brief answer. 1.14. What is the ratio of the Imports(as % of merchandise exports) of 1965 in Argentina to that in Belgium?
Your answer should be compact. 1.55. What is the difference between the highest and the second highest Imports(as % of merchandise exports) in 1962?
Your response must be concise. 0.18. What is the difference between the highest and the second highest Imports(as % of merchandise exports) of 1963?
Keep it short and to the point. 0.1. What is the difference between the highest and the second highest Imports(as % of merchandise exports) in 1964?
Provide a succinct answer. 0.2. What is the difference between the highest and the second highest Imports(as % of merchandise exports) in 1965?
Provide a succinct answer. 2.76. What is the difference between the highest and the lowest Imports(as % of merchandise exports) of 1962?
Ensure brevity in your answer.  7.95. What is the difference between the highest and the lowest Imports(as % of merchandise exports) in 1963?
Provide a short and direct response. 6.8. What is the difference between the highest and the lowest Imports(as % of merchandise exports) of 1964?
Keep it short and to the point. 6.39. What is the difference between the highest and the lowest Imports(as % of merchandise exports) of 1965?
Make the answer very short. 8.31. 